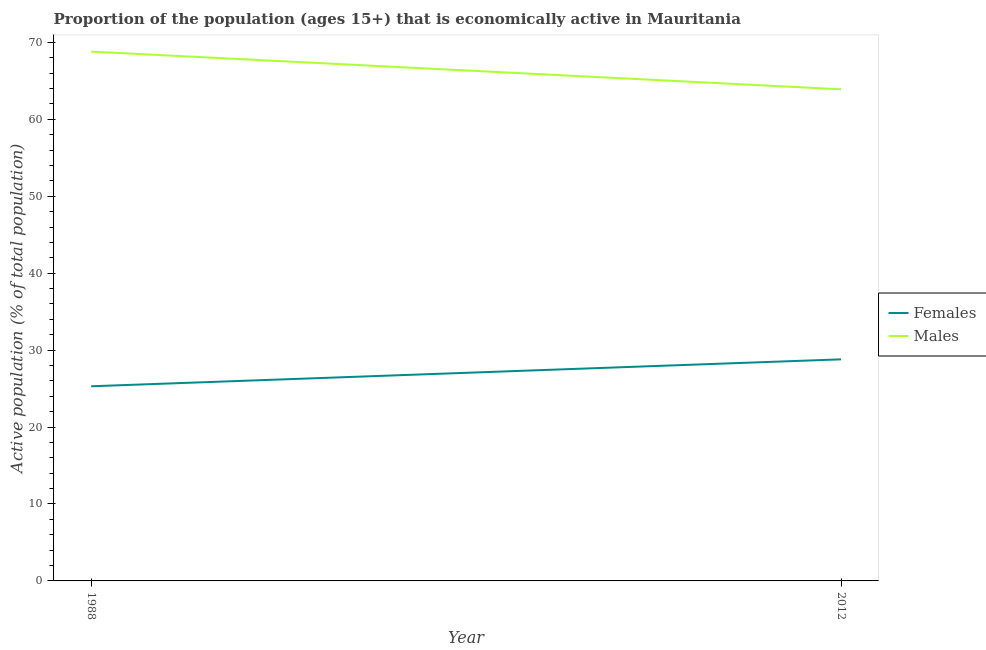How many different coloured lines are there?
Provide a short and direct response. 2. Does the line corresponding to percentage of economically active male population intersect with the line corresponding to percentage of economically active female population?
Ensure brevity in your answer.  No. What is the percentage of economically active female population in 2012?
Provide a succinct answer. 28.8. Across all years, what is the maximum percentage of economically active female population?
Your response must be concise. 28.8. Across all years, what is the minimum percentage of economically active female population?
Your answer should be very brief. 25.3. In which year was the percentage of economically active female population maximum?
Your answer should be very brief. 2012. In which year was the percentage of economically active female population minimum?
Your answer should be very brief. 1988. What is the total percentage of economically active male population in the graph?
Make the answer very short. 132.7. What is the difference between the percentage of economically active male population in 1988 and that in 2012?
Offer a very short reply. 4.9. What is the difference between the percentage of economically active male population in 1988 and the percentage of economically active female population in 2012?
Offer a very short reply. 40. What is the average percentage of economically active male population per year?
Offer a terse response. 66.35. In the year 2012, what is the difference between the percentage of economically active male population and percentage of economically active female population?
Keep it short and to the point. 35.1. What is the ratio of the percentage of economically active male population in 1988 to that in 2012?
Your answer should be very brief. 1.08. Is the percentage of economically active male population in 1988 less than that in 2012?
Make the answer very short. No. How many lines are there?
Keep it short and to the point. 2. Does the graph contain any zero values?
Make the answer very short. No. Does the graph contain grids?
Your answer should be very brief. No. What is the title of the graph?
Provide a short and direct response. Proportion of the population (ages 15+) that is economically active in Mauritania. Does "Commercial service imports" appear as one of the legend labels in the graph?
Your response must be concise. No. What is the label or title of the X-axis?
Your answer should be very brief. Year. What is the label or title of the Y-axis?
Provide a short and direct response. Active population (% of total population). What is the Active population (% of total population) of Females in 1988?
Ensure brevity in your answer.  25.3. What is the Active population (% of total population) of Males in 1988?
Your answer should be very brief. 68.8. What is the Active population (% of total population) of Females in 2012?
Make the answer very short. 28.8. What is the Active population (% of total population) in Males in 2012?
Offer a very short reply. 63.9. Across all years, what is the maximum Active population (% of total population) of Females?
Your answer should be compact. 28.8. Across all years, what is the maximum Active population (% of total population) of Males?
Offer a very short reply. 68.8. Across all years, what is the minimum Active population (% of total population) in Females?
Your response must be concise. 25.3. Across all years, what is the minimum Active population (% of total population) of Males?
Keep it short and to the point. 63.9. What is the total Active population (% of total population) of Females in the graph?
Provide a succinct answer. 54.1. What is the total Active population (% of total population) in Males in the graph?
Your answer should be very brief. 132.7. What is the difference between the Active population (% of total population) in Females in 1988 and that in 2012?
Offer a terse response. -3.5. What is the difference between the Active population (% of total population) in Females in 1988 and the Active population (% of total population) in Males in 2012?
Provide a short and direct response. -38.6. What is the average Active population (% of total population) in Females per year?
Offer a very short reply. 27.05. What is the average Active population (% of total population) of Males per year?
Provide a succinct answer. 66.35. In the year 1988, what is the difference between the Active population (% of total population) of Females and Active population (% of total population) of Males?
Provide a succinct answer. -43.5. In the year 2012, what is the difference between the Active population (% of total population) in Females and Active population (% of total population) in Males?
Make the answer very short. -35.1. What is the ratio of the Active population (% of total population) in Females in 1988 to that in 2012?
Provide a succinct answer. 0.88. What is the ratio of the Active population (% of total population) of Males in 1988 to that in 2012?
Provide a short and direct response. 1.08. What is the difference between the highest and the second highest Active population (% of total population) of Females?
Make the answer very short. 3.5. 